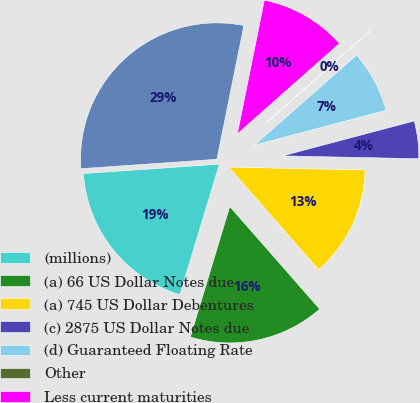<chart> <loc_0><loc_0><loc_500><loc_500><pie_chart><fcel>(millions)<fcel>(a) 66 US Dollar Notes due<fcel>(a) 745 US Dollar Debentures<fcel>(c) 2875 US Dollar Notes due<fcel>(d) Guaranteed Floating Rate<fcel>Other<fcel>Less current maturities<fcel>Balance at year end<nl><fcel>19.22%<fcel>16.13%<fcel>13.21%<fcel>4.45%<fcel>7.37%<fcel>0.05%<fcel>10.29%<fcel>29.26%<nl></chart> 